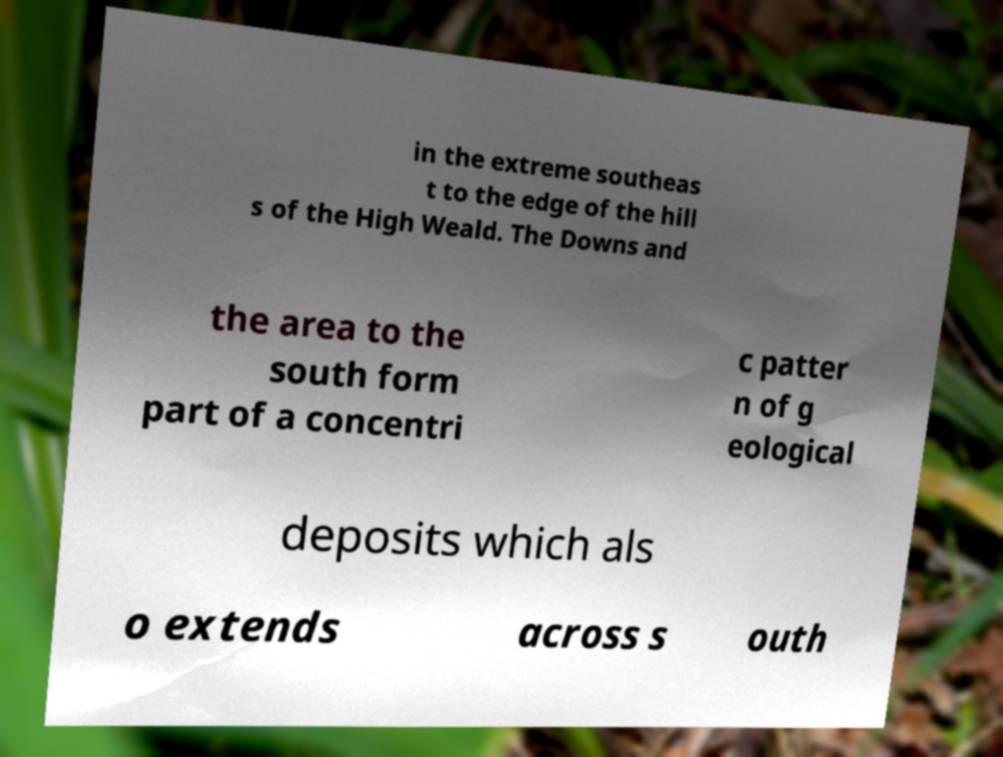Could you extract and type out the text from this image? in the extreme southeas t to the edge of the hill s of the High Weald. The Downs and the area to the south form part of a concentri c patter n of g eological deposits which als o extends across s outh 